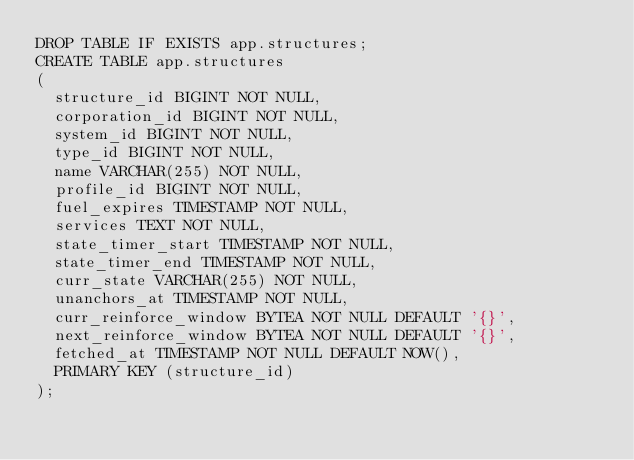Convert code to text. <code><loc_0><loc_0><loc_500><loc_500><_SQL_>DROP TABLE IF EXISTS app.structures;
CREATE TABLE app.structures
(
  structure_id BIGINT NOT NULL,
  corporation_id BIGINT NOT NULL,
  system_id BIGINT NOT NULL,
  type_id BIGINT NOT NULL,
  name VARCHAR(255) NOT NULL,
  profile_id BIGINT NOT NULL,
  fuel_expires TIMESTAMP NOT NULL,
  services TEXT NOT NULL,
  state_timer_start TIMESTAMP NOT NULL,
  state_timer_end TIMESTAMP NOT NULL,
  curr_state VARCHAR(255) NOT NULL,
  unanchors_at TIMESTAMP NOT NULL,
  curr_reinforce_window BYTEA NOT NULL DEFAULT '{}',
  next_reinforce_window BYTEA NOT NULL DEFAULT '{}',
  fetched_at TIMESTAMP NOT NULL DEFAULT NOW(),
  PRIMARY KEY (structure_id)
);
</code> 